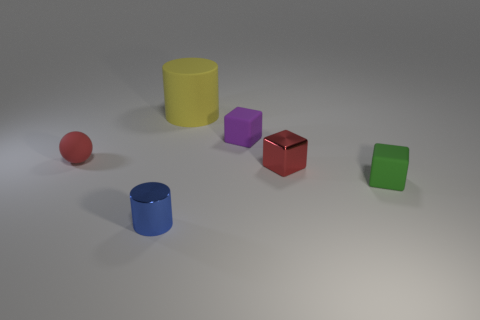What material is the green thing that is the same shape as the tiny purple object?
Give a very brief answer. Rubber. What number of tiny cyan metal cubes are there?
Make the answer very short. 0. There is a metallic object to the right of the large object; what shape is it?
Provide a succinct answer. Cube. There is a cube that is behind the red thing on the right side of the cylinder that is behind the tiny rubber ball; what is its color?
Your answer should be very brief. Purple. What is the shape of the purple thing that is made of the same material as the yellow cylinder?
Provide a succinct answer. Cube. Is the number of large red metal blocks less than the number of tiny rubber blocks?
Give a very brief answer. Yes. Is the green object made of the same material as the tiny blue cylinder?
Offer a very short reply. No. How many other things are there of the same color as the tiny ball?
Ensure brevity in your answer.  1. Is the number of tiny metallic cylinders greater than the number of big blue shiny balls?
Ensure brevity in your answer.  Yes. Is the size of the purple matte block the same as the cylinder in front of the small red sphere?
Ensure brevity in your answer.  Yes. 